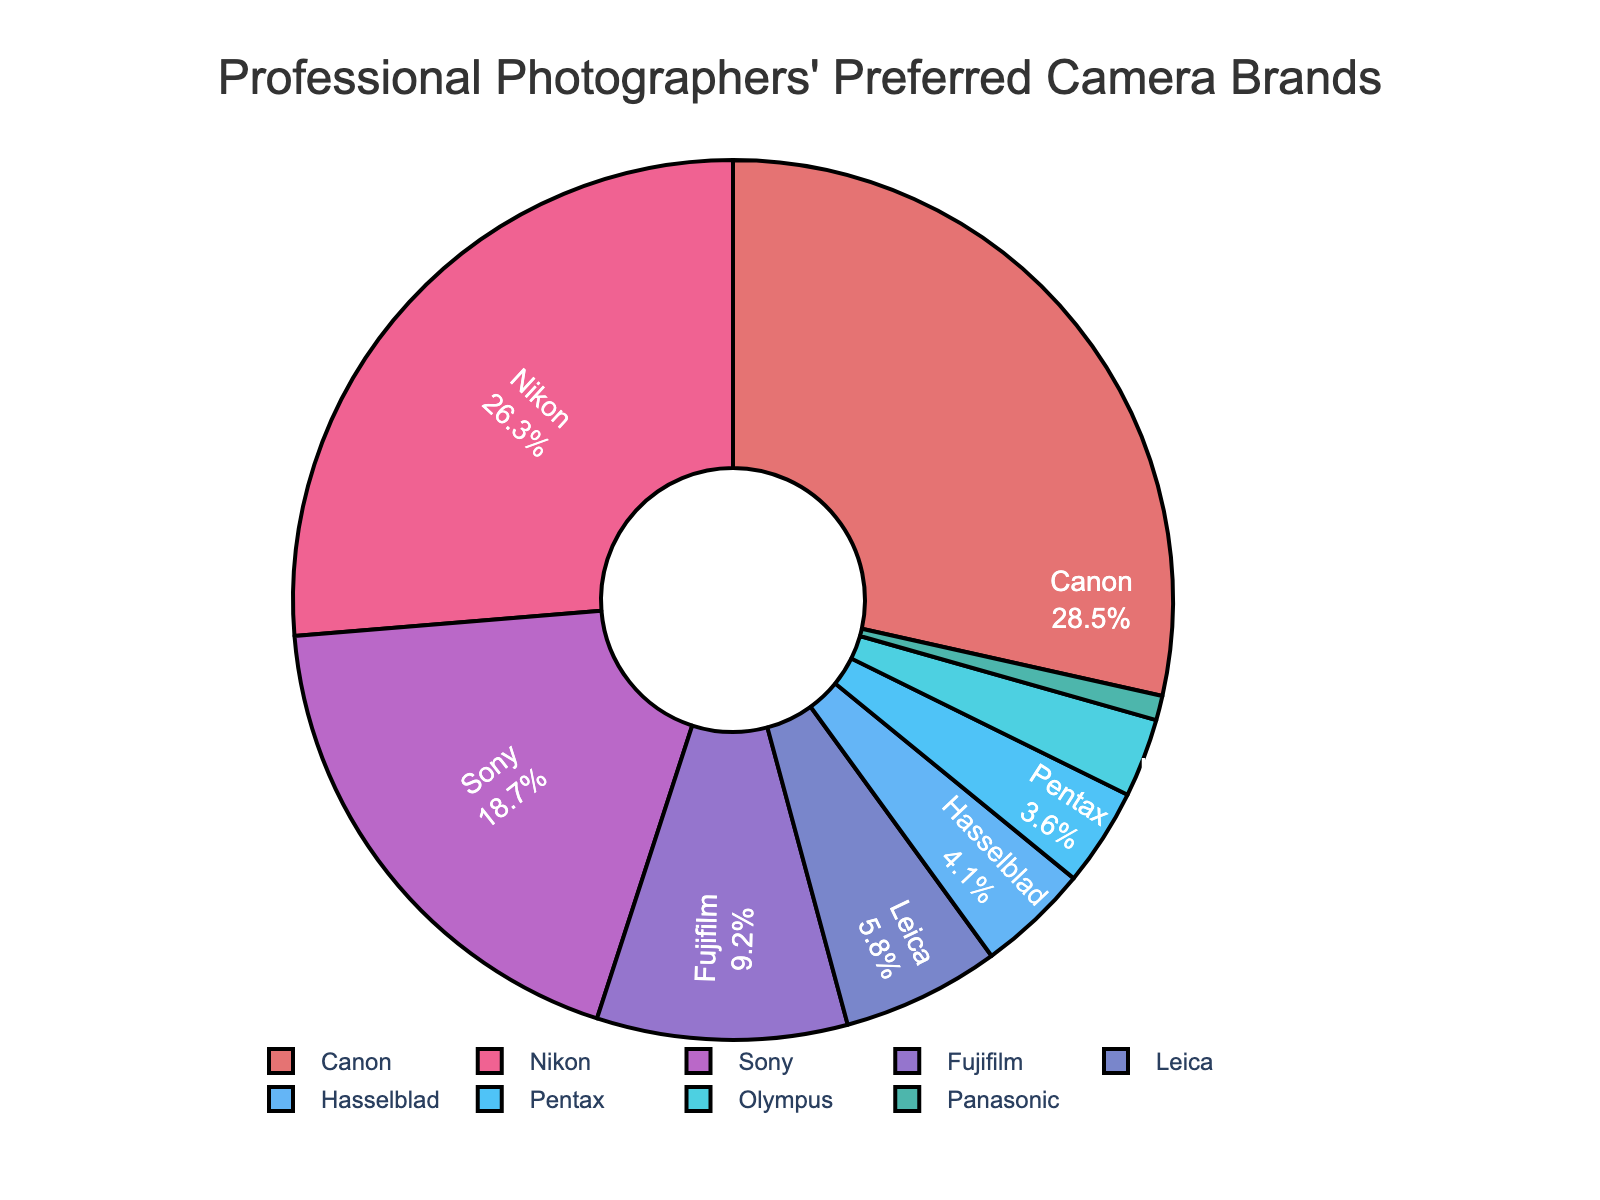Which brand is preferred by the highest percentage of professional photographers? Observing the pie chart, the largest slice is labeled "Canon" with a percentage of 28.5%.
Answer: Canon What is the difference in preference percentage between Canon and Nikon? Canon has a preference percentage of 28.5%, while Nikon has 26.3%. The difference can be calculated as 28.5% - 26.3% = 2.2%.
Answer: 2.2% Combine the percentages of Sony and Fujifilm. What is the total percentage? The pie chart shows Sony with 18.7% and Fujifilm with 9.2%. Adding these together, 18.7% + 9.2% = 27.9%.
Answer: 27.9% Which brand has a higher preference: Leica or Hasselblad? From the chart, Leica's preference percentage is 5.8%, and Hasselblad's is 4.1%. Leica is higher.
Answer: Leica What percentage of photographers prefer either Pentax or Olympus? The pie chart shows Pentax with 3.6% and Olympus with 2.9%. Adding these, 3.6% + 2.9% = 6.5%.
Answer: 6.5% Which color represents the brand Nikon in the chart? Observing the pie chart, the slice labeled “Nikon” is shaded in a pinkish color, likely the second slice in the sequence.
Answer: Pink What is the sum of the percentages for all brands except Canon? Canon has a percentage of 28.5%. The total percentage for all brands is 100%, so for all except Canon: 100% - 28.5% = 71.5%.
Answer: 71.5% If we combine the preferences for Hasselblad, Pentax, Olympus, and Panasonic, do they together surpass Fujifilm's preference percentage? Summing the percentages: Hasselblad (4.1%) + Pentax (3.6%) + Olympus (2.9%) + Panasonic (0.9%) gives 4.1% + 3.6% + 2.9% + 0.9% = 11.5%. Fujifilm's percentage is 9.2%. 11.5% > 9.2%
Answer: Yes 